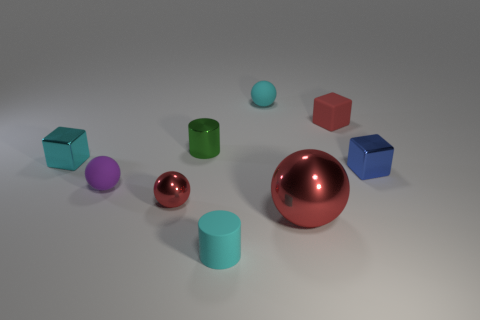Add 1 small red shiny objects. How many objects exist? 10 Subtract all cylinders. How many objects are left? 7 Add 1 matte things. How many matte things exist? 5 Subtract 0 yellow cylinders. How many objects are left? 9 Subtract all big red shiny objects. Subtract all tiny purple rubber things. How many objects are left? 7 Add 5 small cyan spheres. How many small cyan spheres are left? 6 